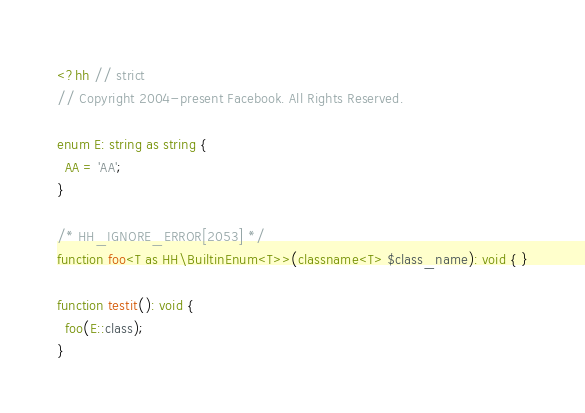Convert code to text. <code><loc_0><loc_0><loc_500><loc_500><_PHP_><?hh // strict
// Copyright 2004-present Facebook. All Rights Reserved.

enum E: string as string {
  AA = 'AA';
}

/* HH_IGNORE_ERROR[2053] */
function foo<T as HH\BuiltinEnum<T>>(classname<T> $class_name): void { }

function testit(): void {
  foo(E::class);
}
</code> 